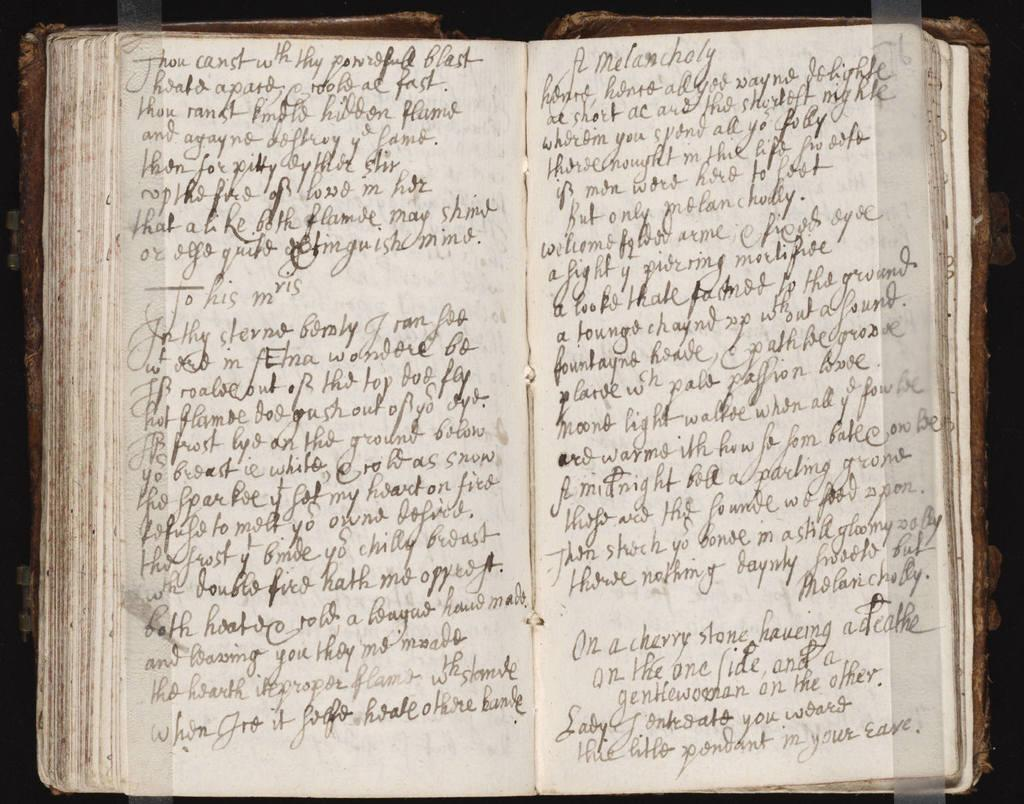<image>
Share a concise interpretation of the image provided. An extremely old book is opened to a page that begins with the words A Melancholy 